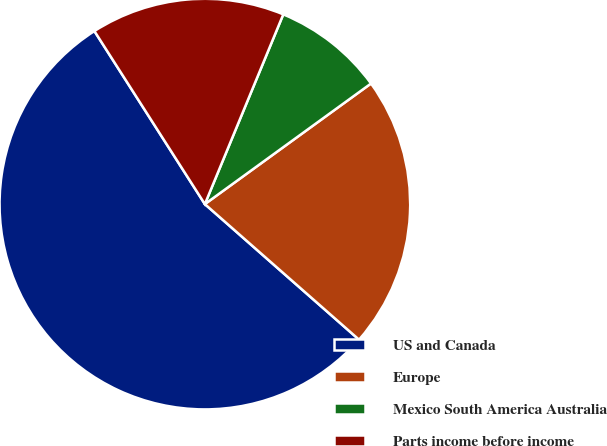Convert chart. <chart><loc_0><loc_0><loc_500><loc_500><pie_chart><fcel>US and Canada<fcel>Europe<fcel>Mexico South America Australia<fcel>Parts income before income<nl><fcel>54.48%<fcel>21.47%<fcel>8.77%<fcel>15.28%<nl></chart> 